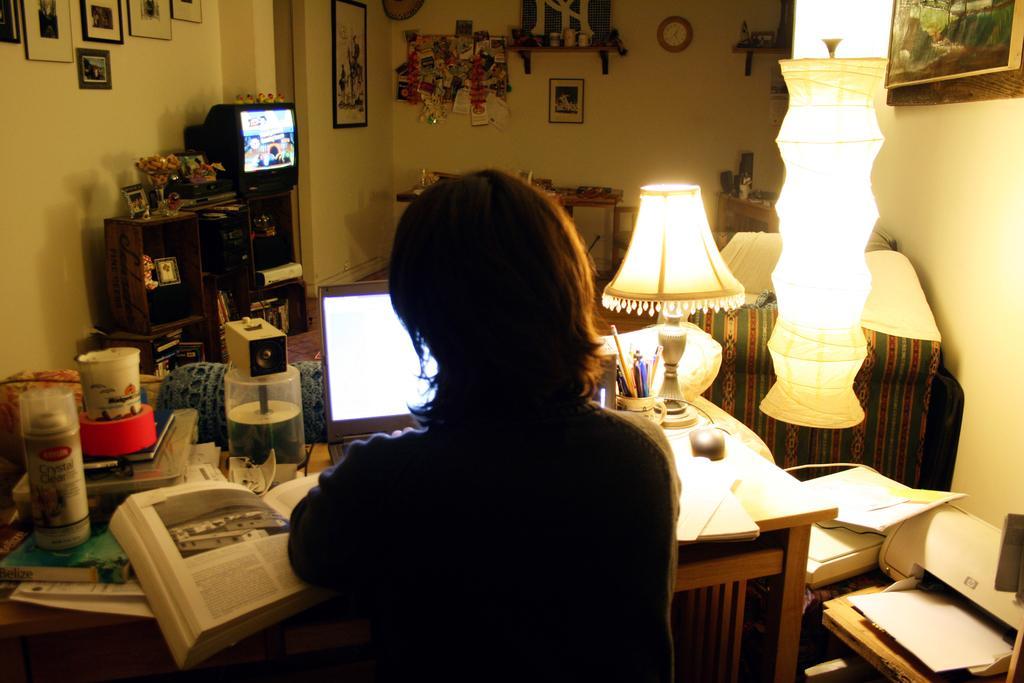Please provide a concise description of this image. Picture of a room. On a wall there are different type of pictures. Clock is attached with the wall. This woman is sitting on a chair. In-front of this woman there is a table, on a table there is a book, laptop, CD holder, spray, jar, pen holder and a lantern lamp. On a rack there is a television. This is a printing machine. Far there is a table. On a rack there is a flower vase. 